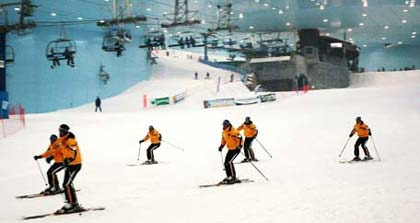How can one differentiate between the front and the back of the ski slope based on the image? To determine the front and back of the ski slope in the image, observe the direction in which the skiers are facing and moving. They are going downhill, indicating the front of the slope. The presence of various structures and the ski lift in the background also helps to identify the depth and orientation of the slope. 